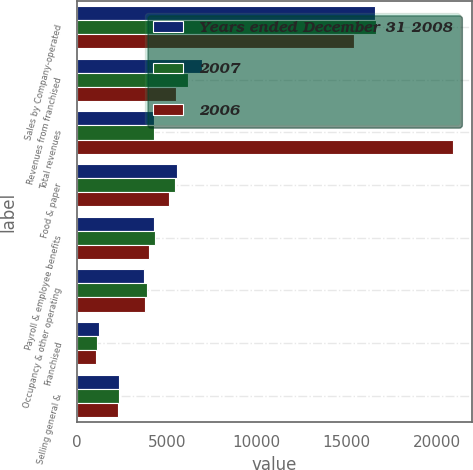Convert chart. <chart><loc_0><loc_0><loc_500><loc_500><stacked_bar_chart><ecel><fcel>Sales by Company-operated<fcel>Revenues from franchised<fcel>Total revenues<fcel>Food & paper<fcel>Payroll & employee benefits<fcel>Occupancy & other operating<fcel>Franchised<fcel>Selling general &<nl><fcel>Years ended December 31 2008<fcel>16560.9<fcel>6961.5<fcel>4315.85<fcel>5586.1<fcel>4300.1<fcel>3766.7<fcel>1230.3<fcel>2355.5<nl><fcel>2007<fcel>16611<fcel>6175.6<fcel>4315.85<fcel>5487.4<fcel>4331.6<fcel>3922.7<fcel>1139.7<fcel>2367<nl><fcel>2006<fcel>15402.4<fcel>5492.8<fcel>20895.2<fcel>5111.8<fcel>3991.1<fcel>3802.2<fcel>1058.1<fcel>2295.7<nl></chart> 